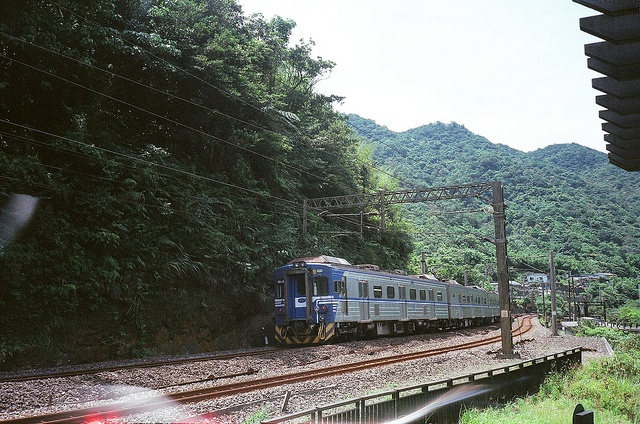Describe the objects in this image and their specific colors. I can see a train in black, gray, and darkgray tones in this image. 